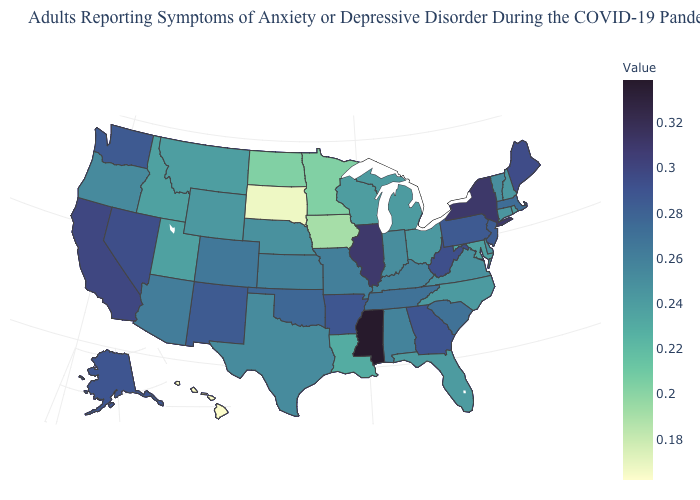Does New Mexico have a higher value than New York?
Write a very short answer. No. Which states hav the highest value in the West?
Write a very short answer. California. Among the states that border West Virginia , which have the highest value?
Answer briefly. Pennsylvania. Which states have the lowest value in the West?
Short answer required. Hawaii. Does Mississippi have the highest value in the USA?
Keep it brief. Yes. Does Massachusetts have a higher value than Idaho?
Give a very brief answer. Yes. 